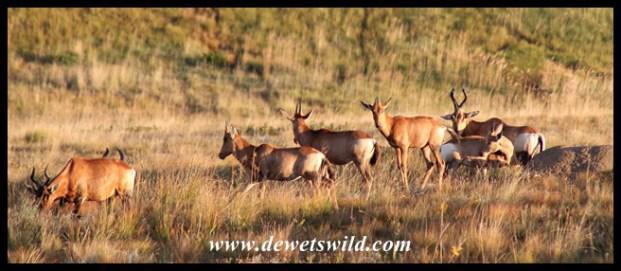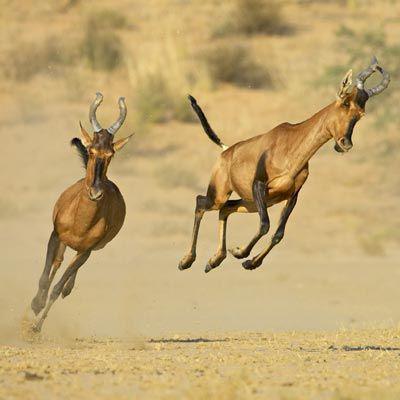The first image is the image on the left, the second image is the image on the right. Assess this claim about the two images: "In one image, none of the horned animals are standing on the ground.". Correct or not? Answer yes or no. Yes. The first image is the image on the left, the second image is the image on the right. Assess this claim about the two images: "At least one photo has two or fewer animals.". Correct or not? Answer yes or no. Yes. 